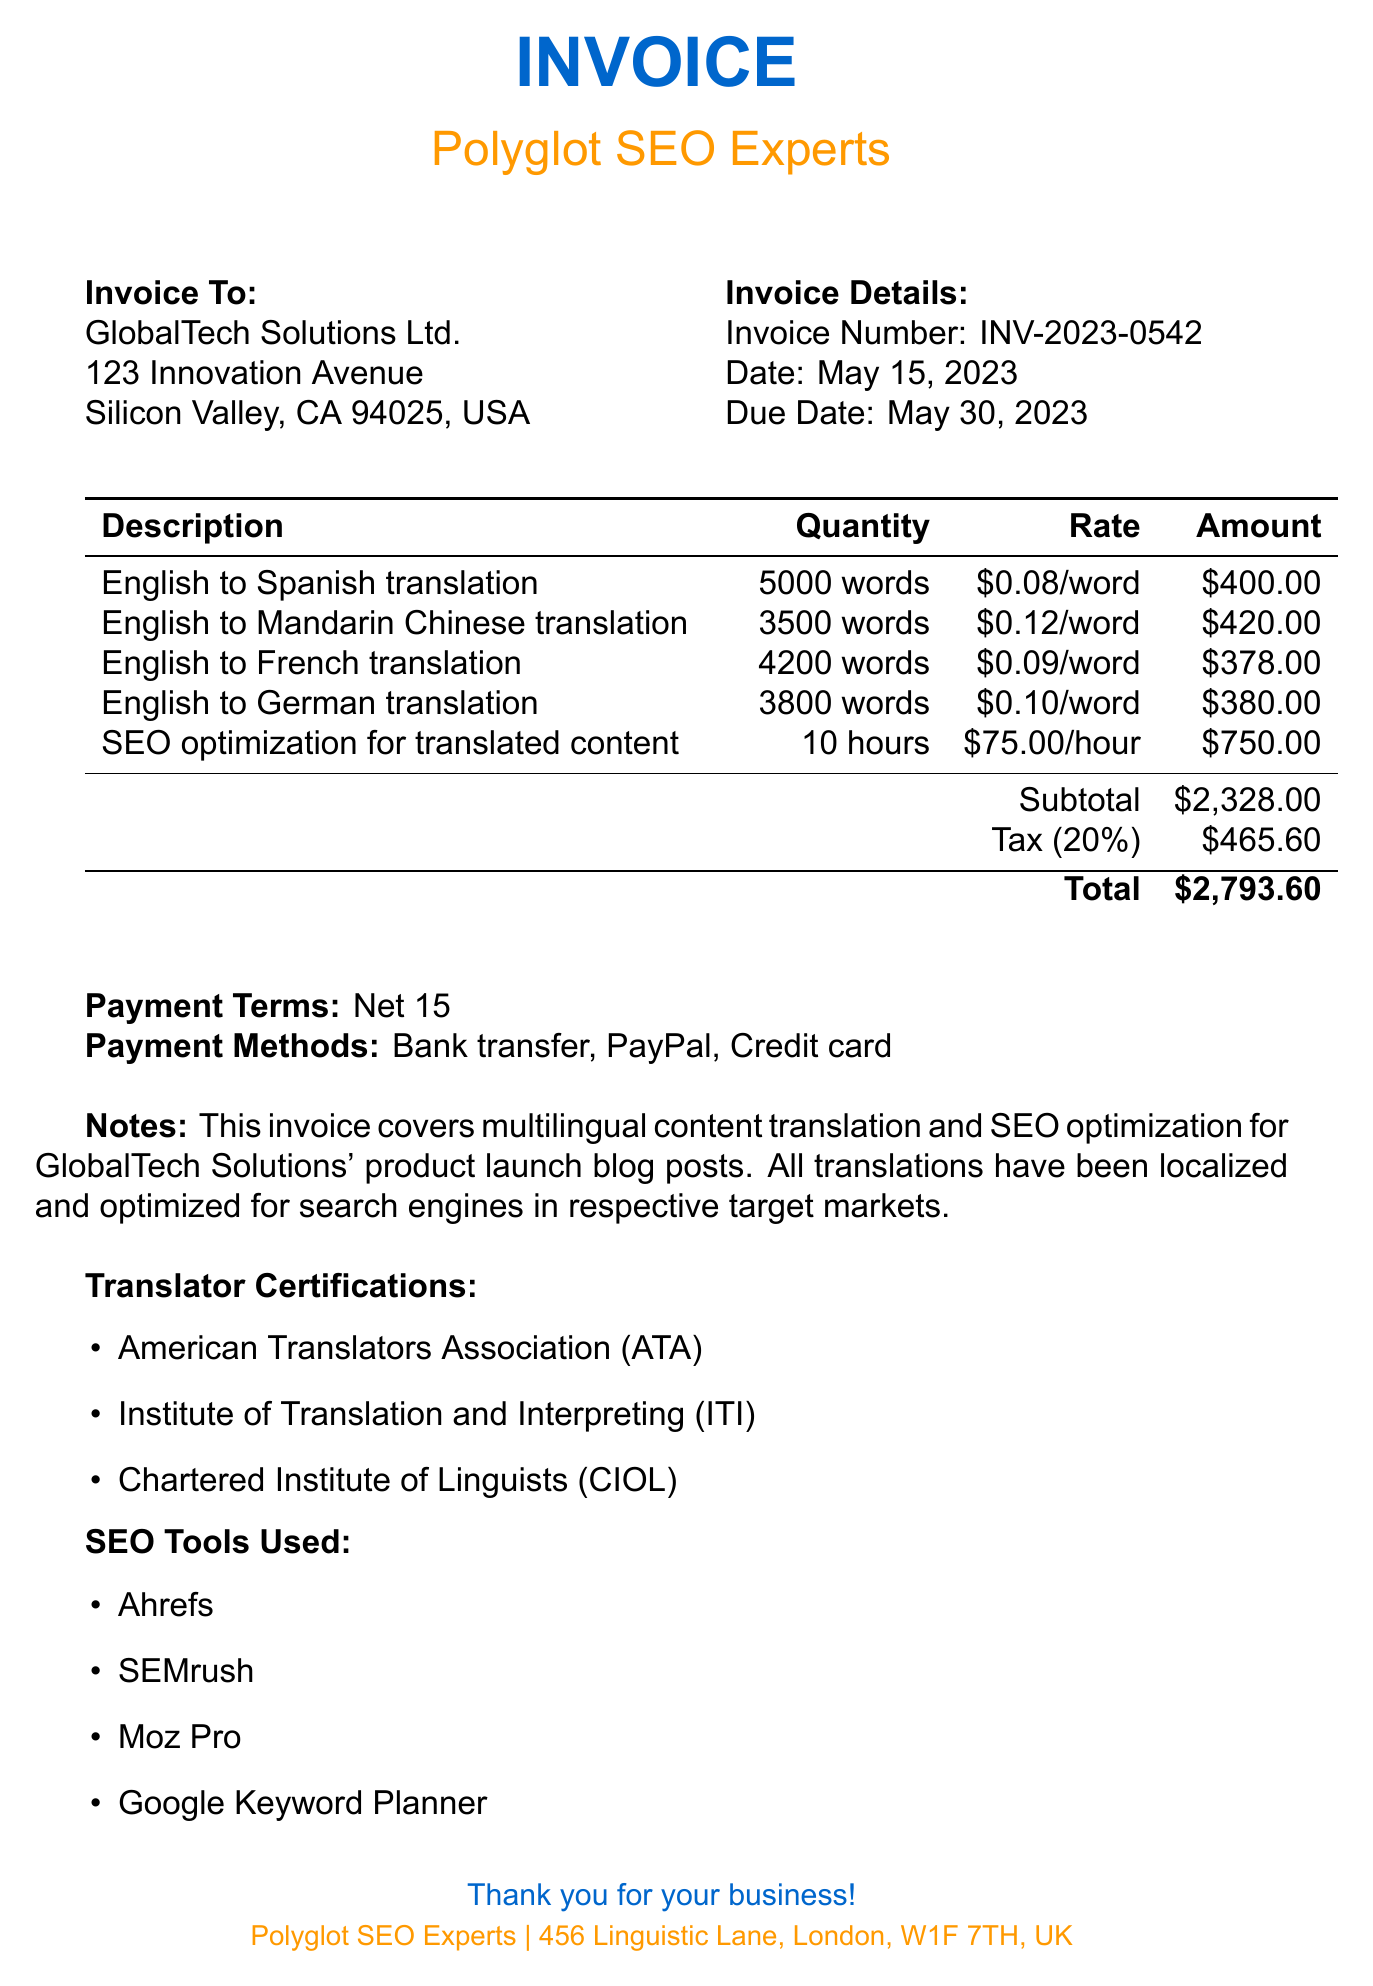What is the invoice number? The invoice number is a unique identifier for the transaction and can be found in the document.
Answer: INV-2023-0542 What is the date of the invoice? The date indicates when the invoice was issued and is stated clearly in the document.
Answer: May 15, 2023 Who is the client? The client's name is the individual or organization receiving the service, which is mentioned in the invoice.
Answer: GlobalTech Solutions Ltd What is the total amount due? This is the final amount that the client needs to pay, calculated after the subtotal and tax are added.
Answer: $2,793.60 How many languages were involved in the translation service? The total number of languages indicates the breadth of the services provided, listed in the items section.
Answer: 4 What is the rate per word for the English to German translation? This rate is specified in the item description for that particular translation service.
Answer: $0.10/word What is the tax rate applied to the invoice? The tax rate shows the percentage of the subtotal that was added as tax, which is mentioned in the document.
Answer: 20% What payment methods are accepted? The accepted payment methods are the options provided for the client to settle the invoice amount.
Answer: Bank transfer, PayPal, Credit card What type of professional certifications do the translators have? These certifications demonstrate the qualifications and professional standards of the translators, as indicated in the invoice.
Answer: American Translators Association (ATA), Institute of Translation and Interpreting (ITI), Chartered Institute of Linguists (CIOL) How many hours were spent on SEO optimization? This number represents the time invested in optimizing the translated content for search engines.
Answer: 10 hours 